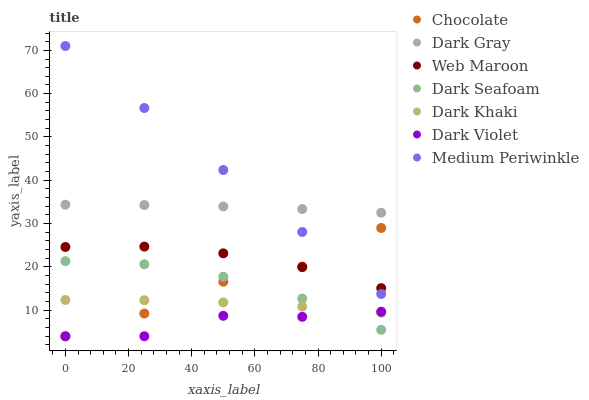Does Dark Violet have the minimum area under the curve?
Answer yes or no. Yes. Does Medium Periwinkle have the maximum area under the curve?
Answer yes or no. Yes. Does Web Maroon have the minimum area under the curve?
Answer yes or no. No. Does Web Maroon have the maximum area under the curve?
Answer yes or no. No. Is Medium Periwinkle the smoothest?
Answer yes or no. Yes. Is Chocolate the roughest?
Answer yes or no. Yes. Is Web Maroon the smoothest?
Answer yes or no. No. Is Web Maroon the roughest?
Answer yes or no. No. Does Dark Violet have the lowest value?
Answer yes or no. Yes. Does Medium Periwinkle have the lowest value?
Answer yes or no. No. Does Medium Periwinkle have the highest value?
Answer yes or no. Yes. Does Web Maroon have the highest value?
Answer yes or no. No. Is Dark Khaki less than Web Maroon?
Answer yes or no. Yes. Is Dark Gray greater than Dark Violet?
Answer yes or no. Yes. Does Web Maroon intersect Medium Periwinkle?
Answer yes or no. Yes. Is Web Maroon less than Medium Periwinkle?
Answer yes or no. No. Is Web Maroon greater than Medium Periwinkle?
Answer yes or no. No. Does Dark Khaki intersect Web Maroon?
Answer yes or no. No. 